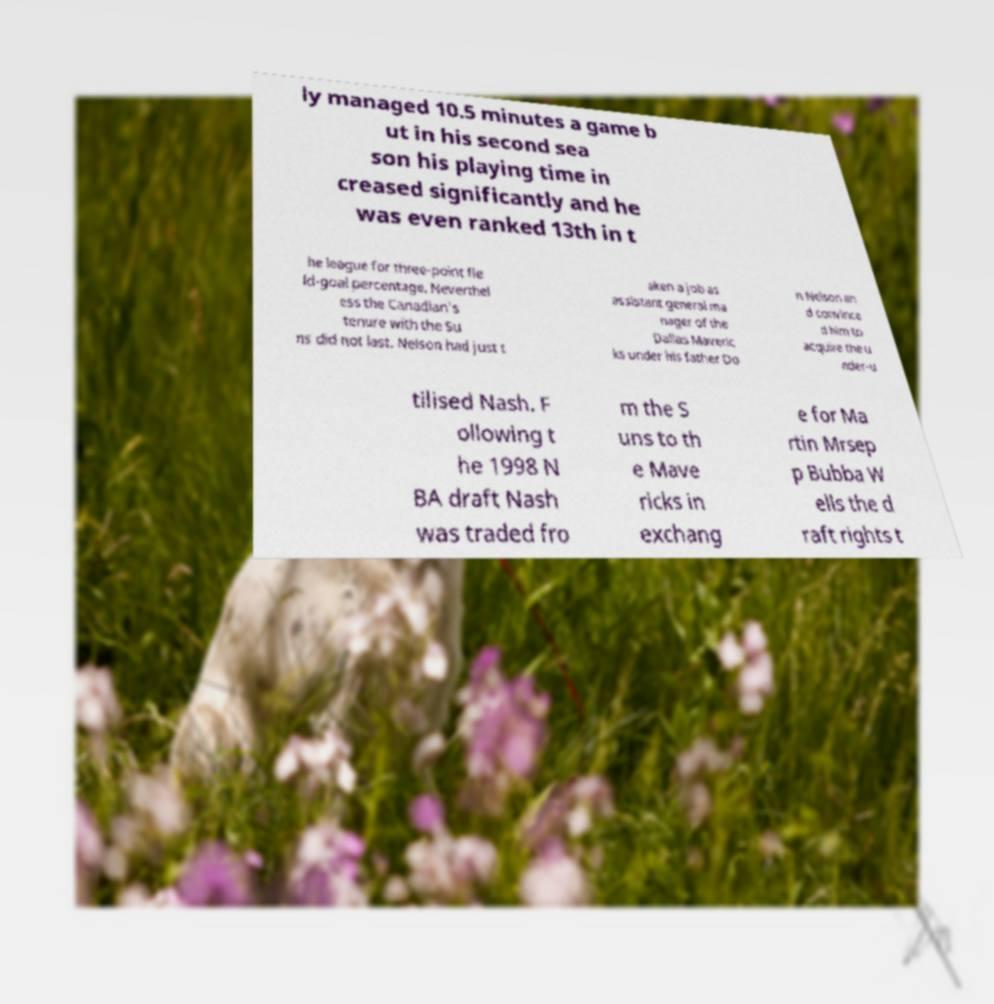I need the written content from this picture converted into text. Can you do that? ly managed 10.5 minutes a game b ut in his second sea son his playing time in creased significantly and he was even ranked 13th in t he league for three-point fie ld-goal percentage. Neverthel ess the Canadian's tenure with the Su ns did not last. Nelson had just t aken a job as assistant general ma nager of the Dallas Maveric ks under his father Do n Nelson an d convince d him to acquire the u nder-u tilised Nash. F ollowing t he 1998 N BA draft Nash was traded fro m the S uns to th e Mave ricks in exchang e for Ma rtin Mrsep p Bubba W ells the d raft rights t 